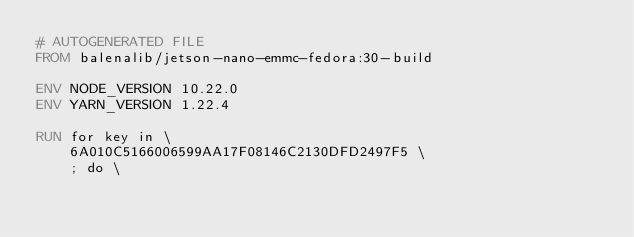Convert code to text. <code><loc_0><loc_0><loc_500><loc_500><_Dockerfile_># AUTOGENERATED FILE
FROM balenalib/jetson-nano-emmc-fedora:30-build

ENV NODE_VERSION 10.22.0
ENV YARN_VERSION 1.22.4

RUN for key in \
	6A010C5166006599AA17F08146C2130DFD2497F5 \
	; do \</code> 